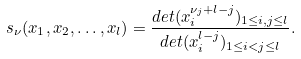<formula> <loc_0><loc_0><loc_500><loc_500>s _ { \nu } ( x _ { 1 } , x _ { 2 } , \dots , x _ { l } ) = \frac { d e t ( x _ { i } ^ { \nu _ { j } + l - j } ) _ { 1 \leq i , j \leq l } } { d e t ( x _ { i } ^ { l - j } ) _ { 1 \leq i < j \leq l } } .</formula> 